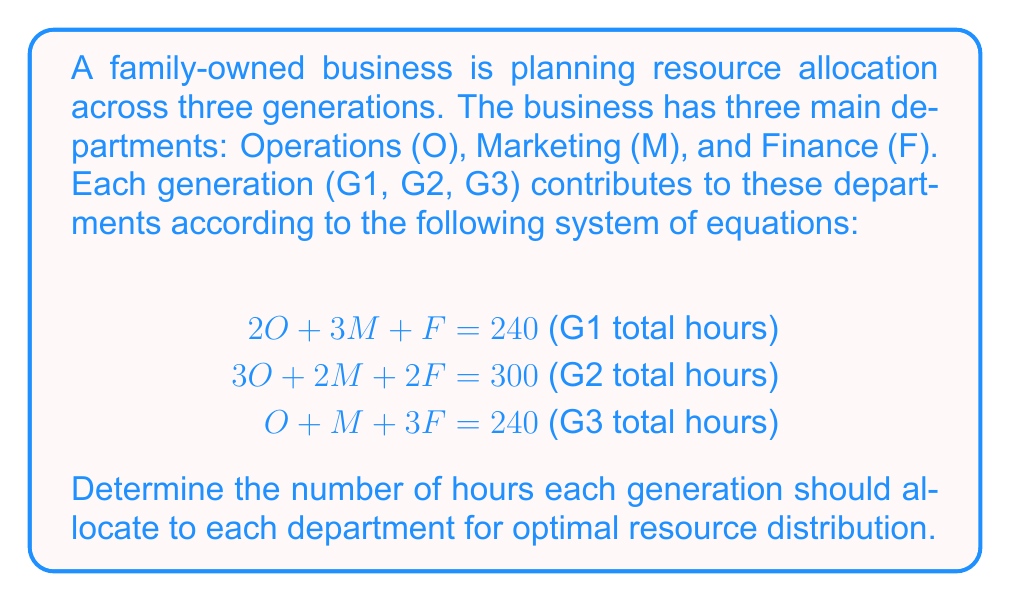What is the answer to this math problem? To solve this system of linear equations, we'll use the Gaussian elimination method:

Step 1: Write the augmented matrix
$$\begin{bmatrix}
2 & 3 & 1 & 240 \\
3 & 2 & 2 & 300 \\
1 & 1 & 3 & 240
\end{bmatrix}$$

Step 2: Use row operations to transform the matrix into row echelon form

a) Multiply R1 by -3/2 and add to R2:
$$\begin{bmatrix}
2 & 3 & 1 & 240 \\
0 & -5/2 & 1/2 & 60 \\
1 & 1 & 3 & 240
\end{bmatrix}$$

b) Multiply R1 by -1/2 and add to R3:
$$\begin{bmatrix}
2 & 3 & 1 & 240 \\
0 & -5/2 & 1/2 & 60 \\
0 & -1/2 & 5/2 & 120
\end{bmatrix}$$

Step 3: Continue row operations to get the reduced row echelon form

c) Multiply R2 by 2/5 to make the leading coefficient 1:
$$\begin{bmatrix}
2 & 3 & 1 & 240 \\
0 & 1 & -1/5 & -24 \\
0 & -1/2 & 5/2 & 120
\end{bmatrix}$$

d) Multiply R2 by 1/2 and add to R3:
$$\begin{bmatrix}
2 & 3 & 1 & 240 \\
0 & 1 & -1/5 & -24 \\
0 & 0 & 13/5 & 108
\end{bmatrix}$$

e) Multiply R3 by 5/13 to make the leading coefficient 1:
$$\begin{bmatrix}
2 & 3 & 1 & 240 \\
0 & 1 & -1/5 & -24 \\
0 & 0 & 1 & 5\cdot\frac{108}{13}
\end{bmatrix}$$

Step 4: Back-substitute to find the values of O, M, and F

F = $5\cdot\frac{108}{13} = \frac{540}{13} \approx 41.54$

M = $-24 + \frac{1}{5}\cdot\frac{540}{13} = -24 + \frac{108}{65} = -\frac{1452}{65} \approx 22.34$

O = $\frac{240 - 3M - F}{2} = \frac{240 - 3(-\frac{1452}{65}) - \frac{540}{13}}{2} = \frac{240 + \frac{4356}{65} - \frac{540}{13}}{2} = \frac{15600 + 4356 - 2700}{130} = \frac{17256}{130} \approx 132.74$

Step 5: Round the results to the nearest whole number for practical application

O ≈ 133 hours
M ≈ 22 hours
F ≈ 42 hours
Answer: Operations: 133 hours, Marketing: 22 hours, Finance: 42 hours 